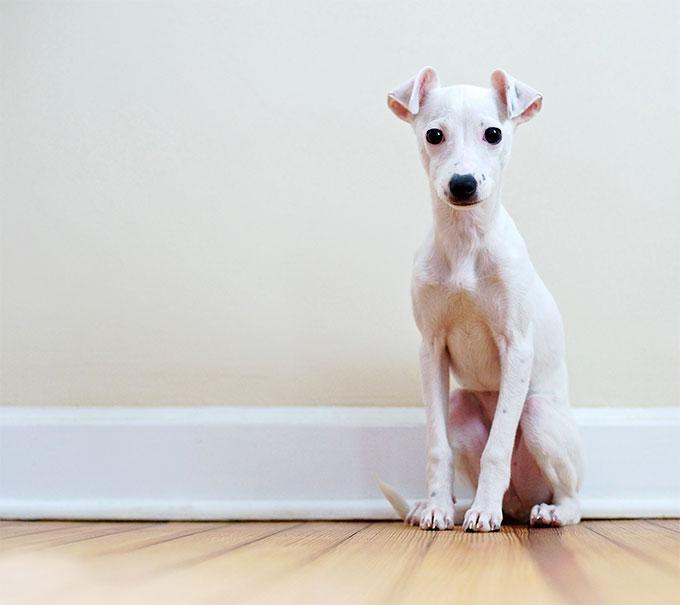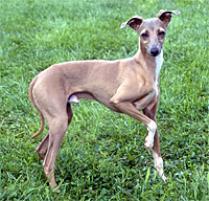The first image is the image on the left, the second image is the image on the right. For the images shown, is this caption "There is a dog with a solid gray face in one of the images." true? Answer yes or no. No. The first image is the image on the left, the second image is the image on the right. Examine the images to the left and right. Is the description "Exactly one of the dogs is standing, and it is posed on green grass with body in profile." accurate? Answer yes or no. Yes. 